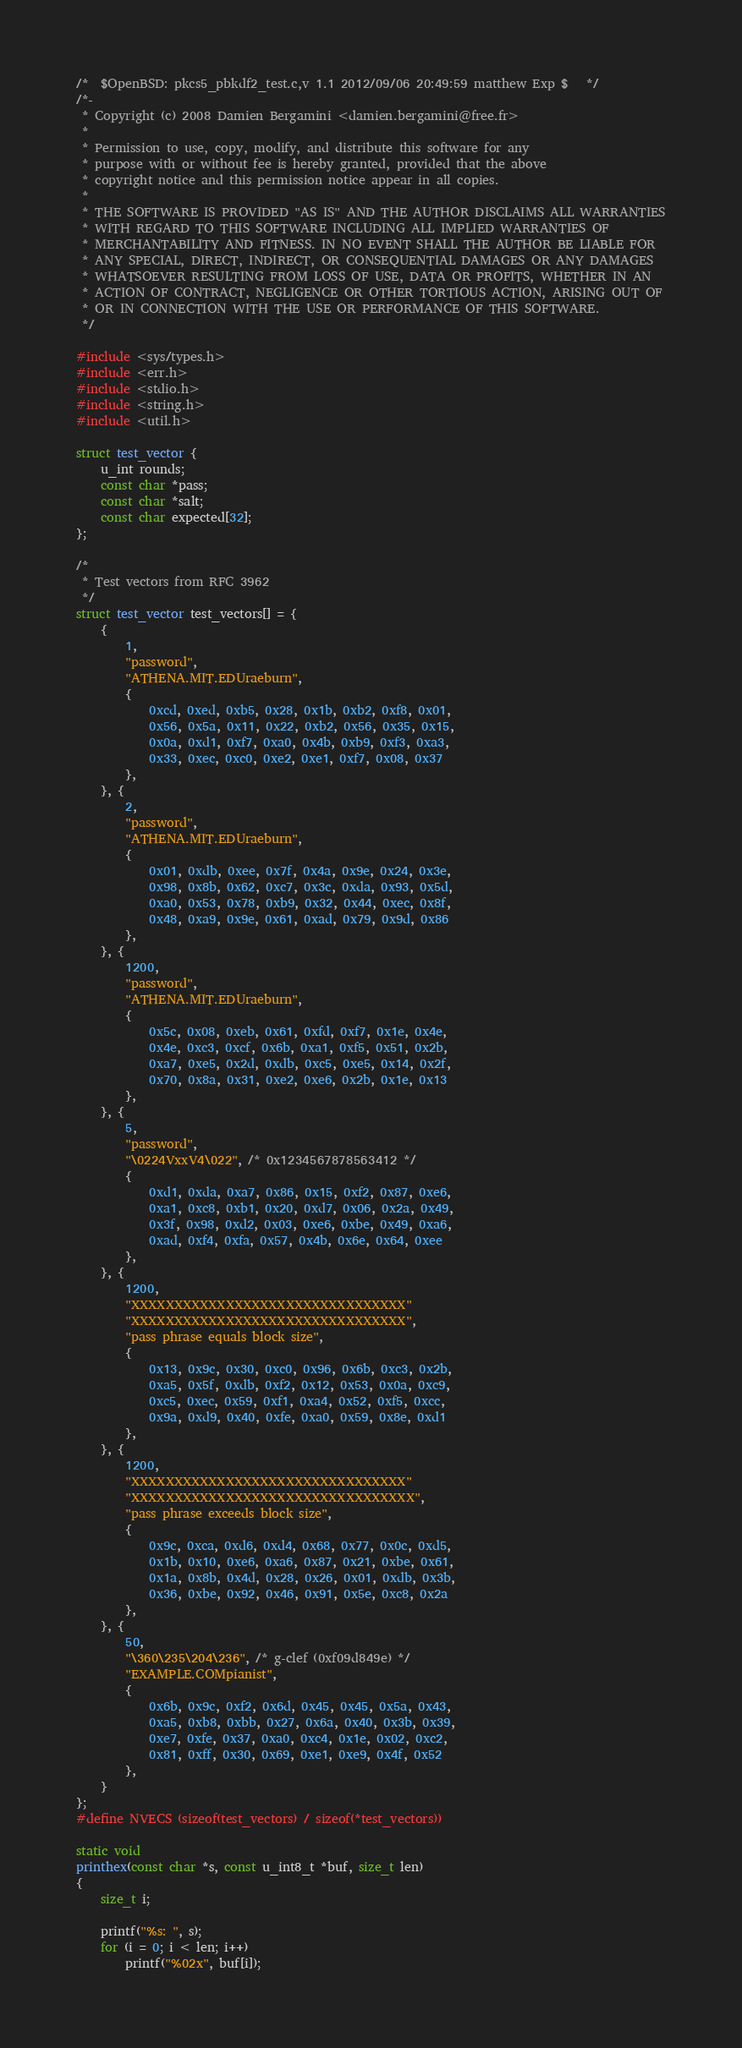<code> <loc_0><loc_0><loc_500><loc_500><_C_>/*	$OpenBSD: pkcs5_pbkdf2_test.c,v 1.1 2012/09/06 20:49:59 matthew Exp $	*/
/*-
 * Copyright (c) 2008 Damien Bergamini <damien.bergamini@free.fr>
 *
 * Permission to use, copy, modify, and distribute this software for any
 * purpose with or without fee is hereby granted, provided that the above
 * copyright notice and this permission notice appear in all copies.
 *
 * THE SOFTWARE IS PROVIDED "AS IS" AND THE AUTHOR DISCLAIMS ALL WARRANTIES
 * WITH REGARD TO THIS SOFTWARE INCLUDING ALL IMPLIED WARRANTIES OF
 * MERCHANTABILITY AND FITNESS. IN NO EVENT SHALL THE AUTHOR BE LIABLE FOR
 * ANY SPECIAL, DIRECT, INDIRECT, OR CONSEQUENTIAL DAMAGES OR ANY DAMAGES
 * WHATSOEVER RESULTING FROM LOSS OF USE, DATA OR PROFITS, WHETHER IN AN
 * ACTION OF CONTRACT, NEGLIGENCE OR OTHER TORTIOUS ACTION, ARISING OUT OF
 * OR IN CONNECTION WITH THE USE OR PERFORMANCE OF THIS SOFTWARE.
 */

#include <sys/types.h>
#include <err.h>
#include <stdio.h>
#include <string.h>
#include <util.h>

struct test_vector {
	u_int rounds;
	const char *pass;
	const char *salt;
	const char expected[32];
};

/*
 * Test vectors from RFC 3962
 */
struct test_vector test_vectors[] = {
	{
		1,
		"password",
		"ATHENA.MIT.EDUraeburn",
		{
			0xcd, 0xed, 0xb5, 0x28, 0x1b, 0xb2, 0xf8, 0x01,
			0x56, 0x5a, 0x11, 0x22, 0xb2, 0x56, 0x35, 0x15,
			0x0a, 0xd1, 0xf7, 0xa0, 0x4b, 0xb9, 0xf3, 0xa3,
			0x33, 0xec, 0xc0, 0xe2, 0xe1, 0xf7, 0x08, 0x37
		},
	}, {
		2,
		"password",
		"ATHENA.MIT.EDUraeburn",
		{
			0x01, 0xdb, 0xee, 0x7f, 0x4a, 0x9e, 0x24, 0x3e, 
			0x98, 0x8b, 0x62, 0xc7, 0x3c, 0xda, 0x93, 0x5d,
			0xa0, 0x53, 0x78, 0xb9, 0x32, 0x44, 0xec, 0x8f,
			0x48, 0xa9, 0x9e, 0x61, 0xad, 0x79, 0x9d, 0x86
		},
	}, {
		1200,
		"password",
		"ATHENA.MIT.EDUraeburn",
		{
			0x5c, 0x08, 0xeb, 0x61, 0xfd, 0xf7, 0x1e, 0x4e,
			0x4e, 0xc3, 0xcf, 0x6b, 0xa1, 0xf5, 0x51, 0x2b,
			0xa7, 0xe5, 0x2d, 0xdb, 0xc5, 0xe5, 0x14, 0x2f,
			0x70, 0x8a, 0x31, 0xe2, 0xe6, 0x2b, 0x1e, 0x13
		},
	}, {
		5,
		"password",
		"\0224VxxV4\022", /* 0x1234567878563412 */
		{
			0xd1, 0xda, 0xa7, 0x86, 0x15, 0xf2, 0x87, 0xe6,
			0xa1, 0xc8, 0xb1, 0x20, 0xd7, 0x06, 0x2a, 0x49,
			0x3f, 0x98, 0xd2, 0x03, 0xe6, 0xbe, 0x49, 0xa6,
			0xad, 0xf4, 0xfa, 0x57, 0x4b, 0x6e, 0x64, 0xee
		},
	}, {
		1200,
		"XXXXXXXXXXXXXXXXXXXXXXXXXXXXXXXX"
		"XXXXXXXXXXXXXXXXXXXXXXXXXXXXXXXX",
		"pass phrase equals block size",
		{
			0x13, 0x9c, 0x30, 0xc0, 0x96, 0x6b, 0xc3, 0x2b,
			0xa5, 0x5f, 0xdb, 0xf2, 0x12, 0x53, 0x0a, 0xc9,
			0xc5, 0xec, 0x59, 0xf1, 0xa4, 0x52, 0xf5, 0xcc,
			0x9a, 0xd9, 0x40, 0xfe, 0xa0, 0x59, 0x8e, 0xd1
		},
	}, {
		1200,
		"XXXXXXXXXXXXXXXXXXXXXXXXXXXXXXXX"
		"XXXXXXXXXXXXXXXXXXXXXXXXXXXXXXXXX",
		"pass phrase exceeds block size",
		{
			0x9c, 0xca, 0xd6, 0xd4, 0x68, 0x77, 0x0c, 0xd5,
			0x1b, 0x10, 0xe6, 0xa6, 0x87, 0x21, 0xbe, 0x61,
			0x1a, 0x8b, 0x4d, 0x28, 0x26, 0x01, 0xdb, 0x3b,
			0x36, 0xbe, 0x92, 0x46, 0x91, 0x5e, 0xc8, 0x2a
		},
	}, {
		50,
		"\360\235\204\236", /* g-clef (0xf09d849e) */
		"EXAMPLE.COMpianist",
		{
			0x6b, 0x9c, 0xf2, 0x6d, 0x45, 0x45, 0x5a, 0x43,
			0xa5, 0xb8, 0xbb, 0x27, 0x6a, 0x40, 0x3b, 0x39,
			0xe7, 0xfe, 0x37, 0xa0, 0xc4, 0x1e, 0x02, 0xc2,
			0x81, 0xff, 0x30, 0x69, 0xe1, 0xe9, 0x4f, 0x52
		},
	}
};
#define NVECS (sizeof(test_vectors) / sizeof(*test_vectors))

static void
printhex(const char *s, const u_int8_t *buf, size_t len)
{
	size_t i;

	printf("%s: ", s);
	for (i = 0; i < len; i++)
		printf("%02x", buf[i]);</code> 